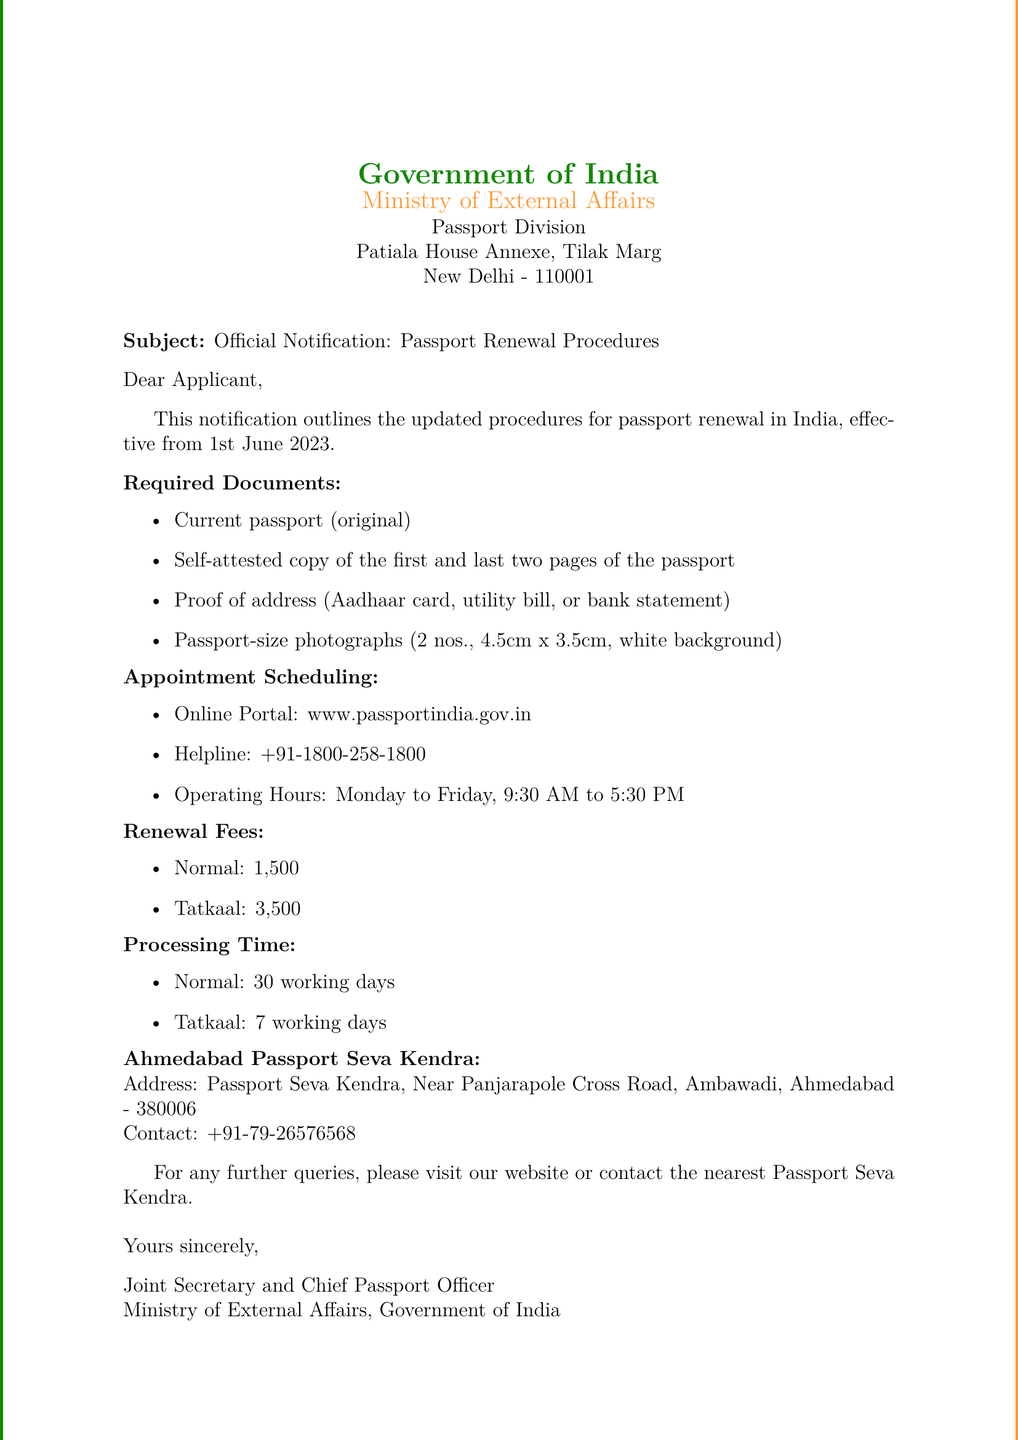What is the effective date of the updated procedures? The document states that the updated procedures for passport renewal are effective from 1st June 2023.
Answer: 1st June 2023 What is the normal renewal fee? The normal renewal fee is mentioned in the document as ₹1,500.
Answer: ₹1,500 How many passport-size photographs are required? The document specifies that 2 passport-size photographs are required.
Answer: 2 What is the processing time for Tatkaal service? The document indicates that the processing time for the Tatkaal service is 7 working days.
Answer: 7 working days What is the helpline number provided in the document? The helpline number for appointment scheduling is stated as +91-1800-258-1800.
Answer: +91-1800-258-1800 Where is the Ahmedabad Passport Seva Kendra located? The location of the Ahmedabad Passport Seva Kendra is provided as Near Panjarapole Cross Road, Ambawadi, Ahmedabad - 380006.
Answer: Near Panjarapole Cross Road, Ambawadi, Ahmedabad - 380006 Which documents are required for passport renewal? The document lists several required documents including the current passport and proof of address.
Answer: Current passport, proof of address What are the operating hours for the helpline? The document mentions that the operating hours for the helpline are Monday to Friday, 9:30 AM to 5:30 PM.
Answer: Monday to Friday, 9:30 AM to 5:30 PM What is the renewal fee for Tatkaal service? The document specifies that the renewal fee for the Tatkaal service is ₹3,500.
Answer: ₹3,500 